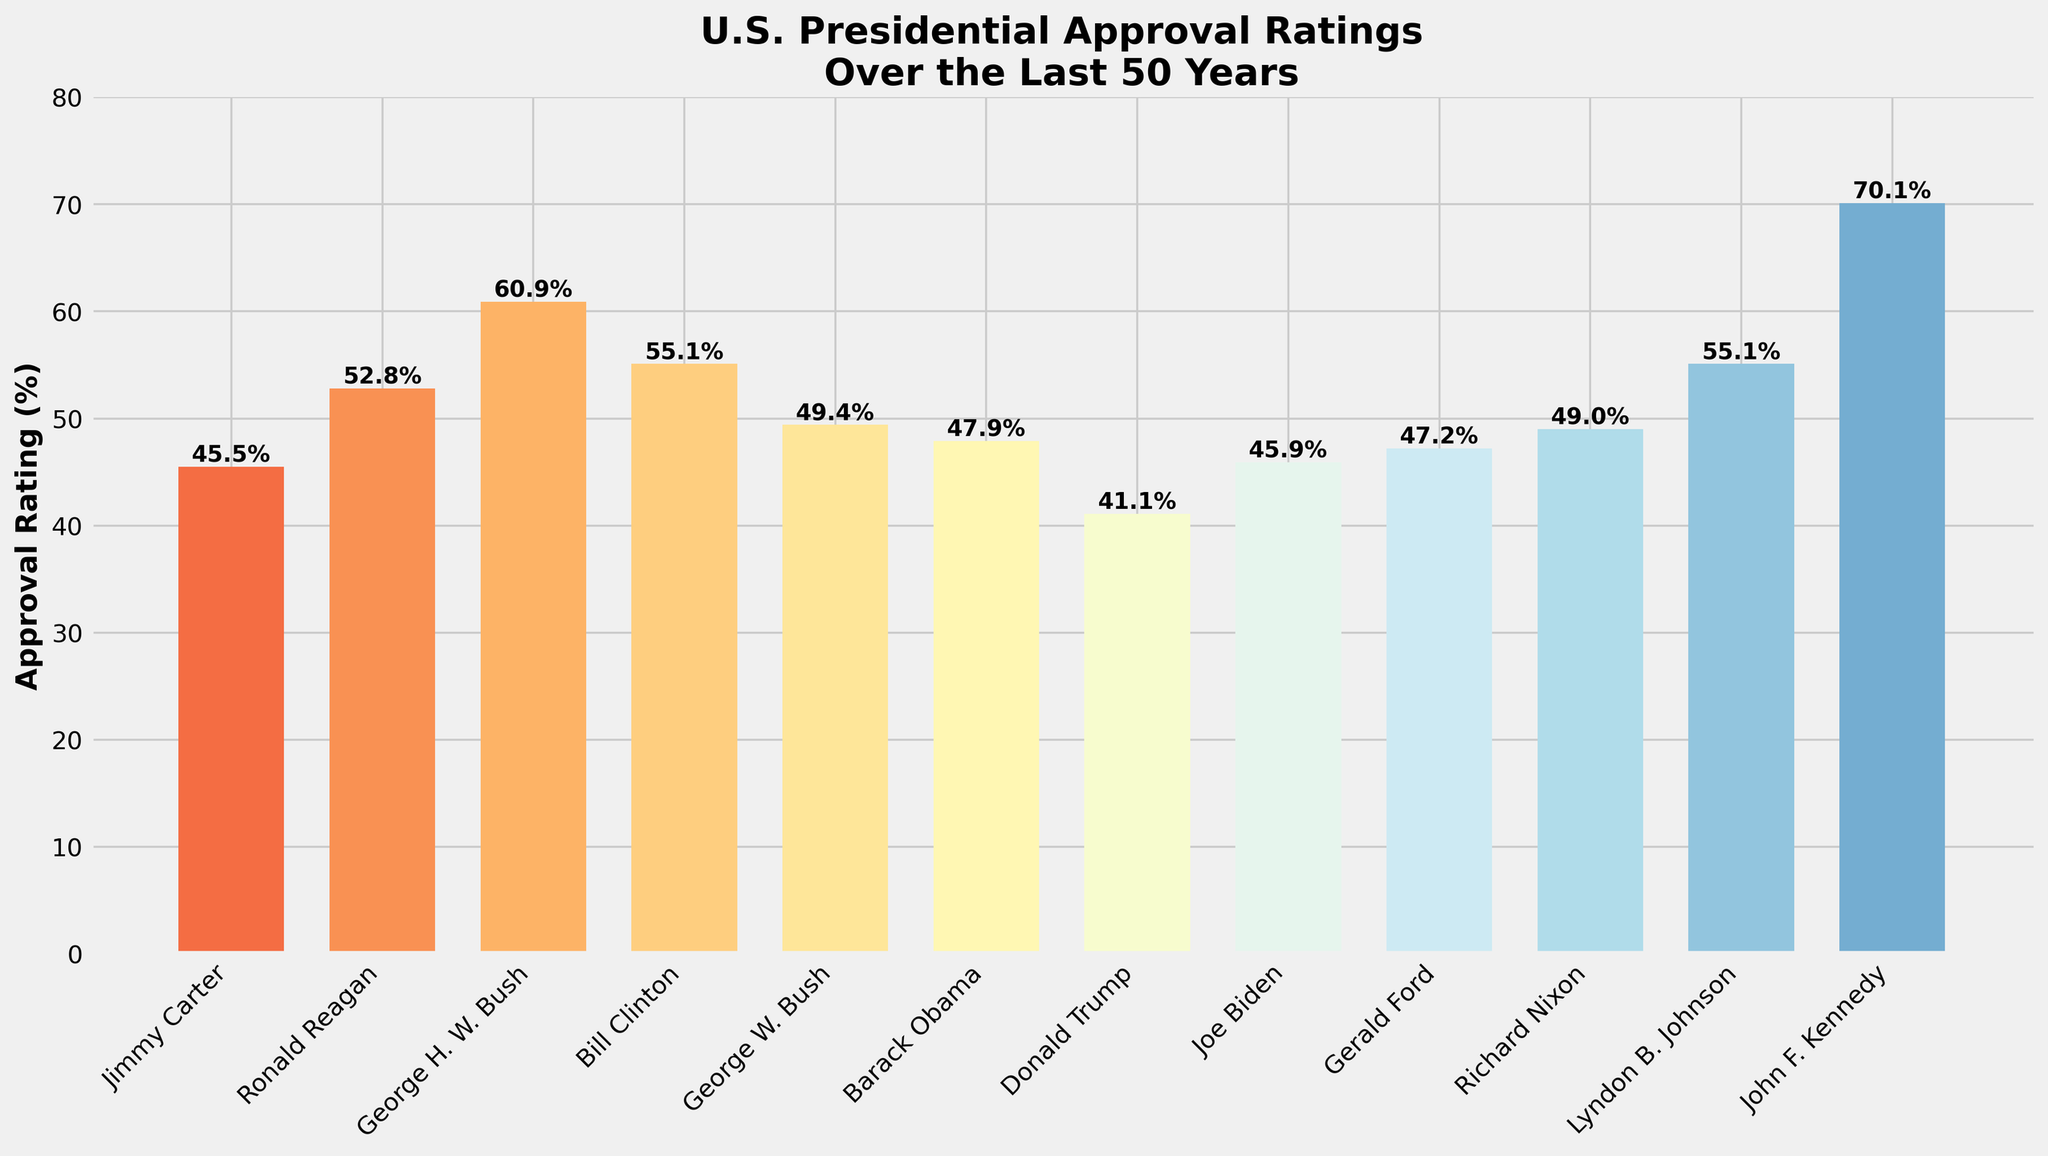Which President has the highest approval rating? The bar corresponding to John F. Kennedy reaches the highest point at 70.1%.
Answer: John F. Kennedy Who are the two Presidents with the lowest approval ratings and what are their values? The bars for Donald Trump and Richard Nixon are the lowest, with approval ratings of 41.1% and 49.0% respectively.
Answer: Donald Trump (41.1%), Richard Nixon (49.0%) What is the average approval rating of all Presidents shown? Sum the approval ratings (45.5 + 52.8 + 60.9 + 55.1 + 49.4 + 47.9 + 41.1 + 45.9 + 47.2 + 49.0 + 55.1 + 70.1) to get 620.0, then divide by the number of Presidents (12). The average is 620.0 / 12 ≈ 51.7%.
Answer: 51.7% How many Presidents have an approval rating above 50%? Count the bars that have heights above the 50% mark: Reagan, Bush Sr., Clinton, Johnson, and Kennedy.
Answer: 5 Which Presidents have an approval rating between 45% and 50%? Identify bars with heights corresponding to approval ratings between 45% and 50%: Jimmy Carter, Barack Obama, Gerald Ford, and Richard Nixon.
Answer: Jimmy Carter, Barack Obama, Gerald Ford, Richard Nixon What is the difference in approval rating between the President with the highest and the President with the lowest rating? Subtract the lowest approval rating (41.1% for Donald Trump) from the highest (70.1% for John F. Kennedy). The difference is 70.1% - 41.1% = 29%.
Answer: 29% What is the combined approval rating of George H.W. Bush and George W. Bush? Add the approval ratings of George H.W. Bush (60.9%) and George W. Bush (49.4%). The combined rating is 60.9 + 49.4 = 110.3%.
Answer: 110.3% Which President who served in the 21st century has the highest approval rating and what is it? Barack Obama (47.9%) and Donald Trump (41.1%) served in the 21st century. Comparing these, Barack Obama has the higher rating.
Answer: Barack Obama (47.9%) How does Joe Biden's approval rating compare to Barack Obama's? Compare the bars: Joe Biden's approval rating is 45.9%, while Barack Obama's is 47.9%. Biden’s rating is lower.
Answer: Joe Biden's is lower What is the median approval rating of the Presidents shown? Arrange the approval ratings in ascending order: 41.1, 45.5, 45.9, 47.2, 47.9, 49.0, 49.4, 52.8, 55.1, 55.1, 60.9, 70.1. With 12 data points, the median is the average of the 6th and 7th values: (49.0 + 49.4) / 2 = 49.2%.
Answer: 49.2% 